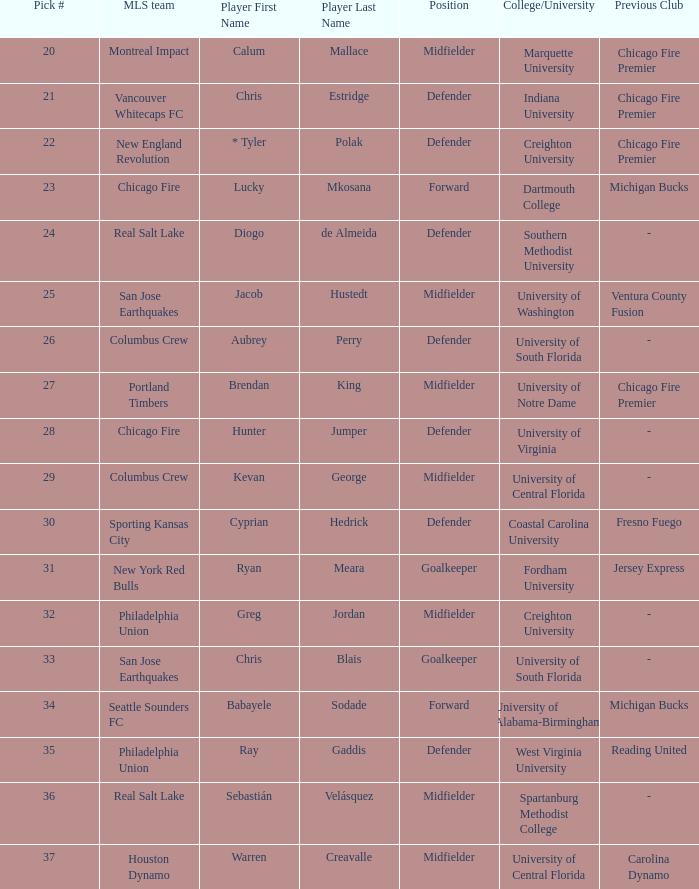What draft number is kevan george? 29.0. 